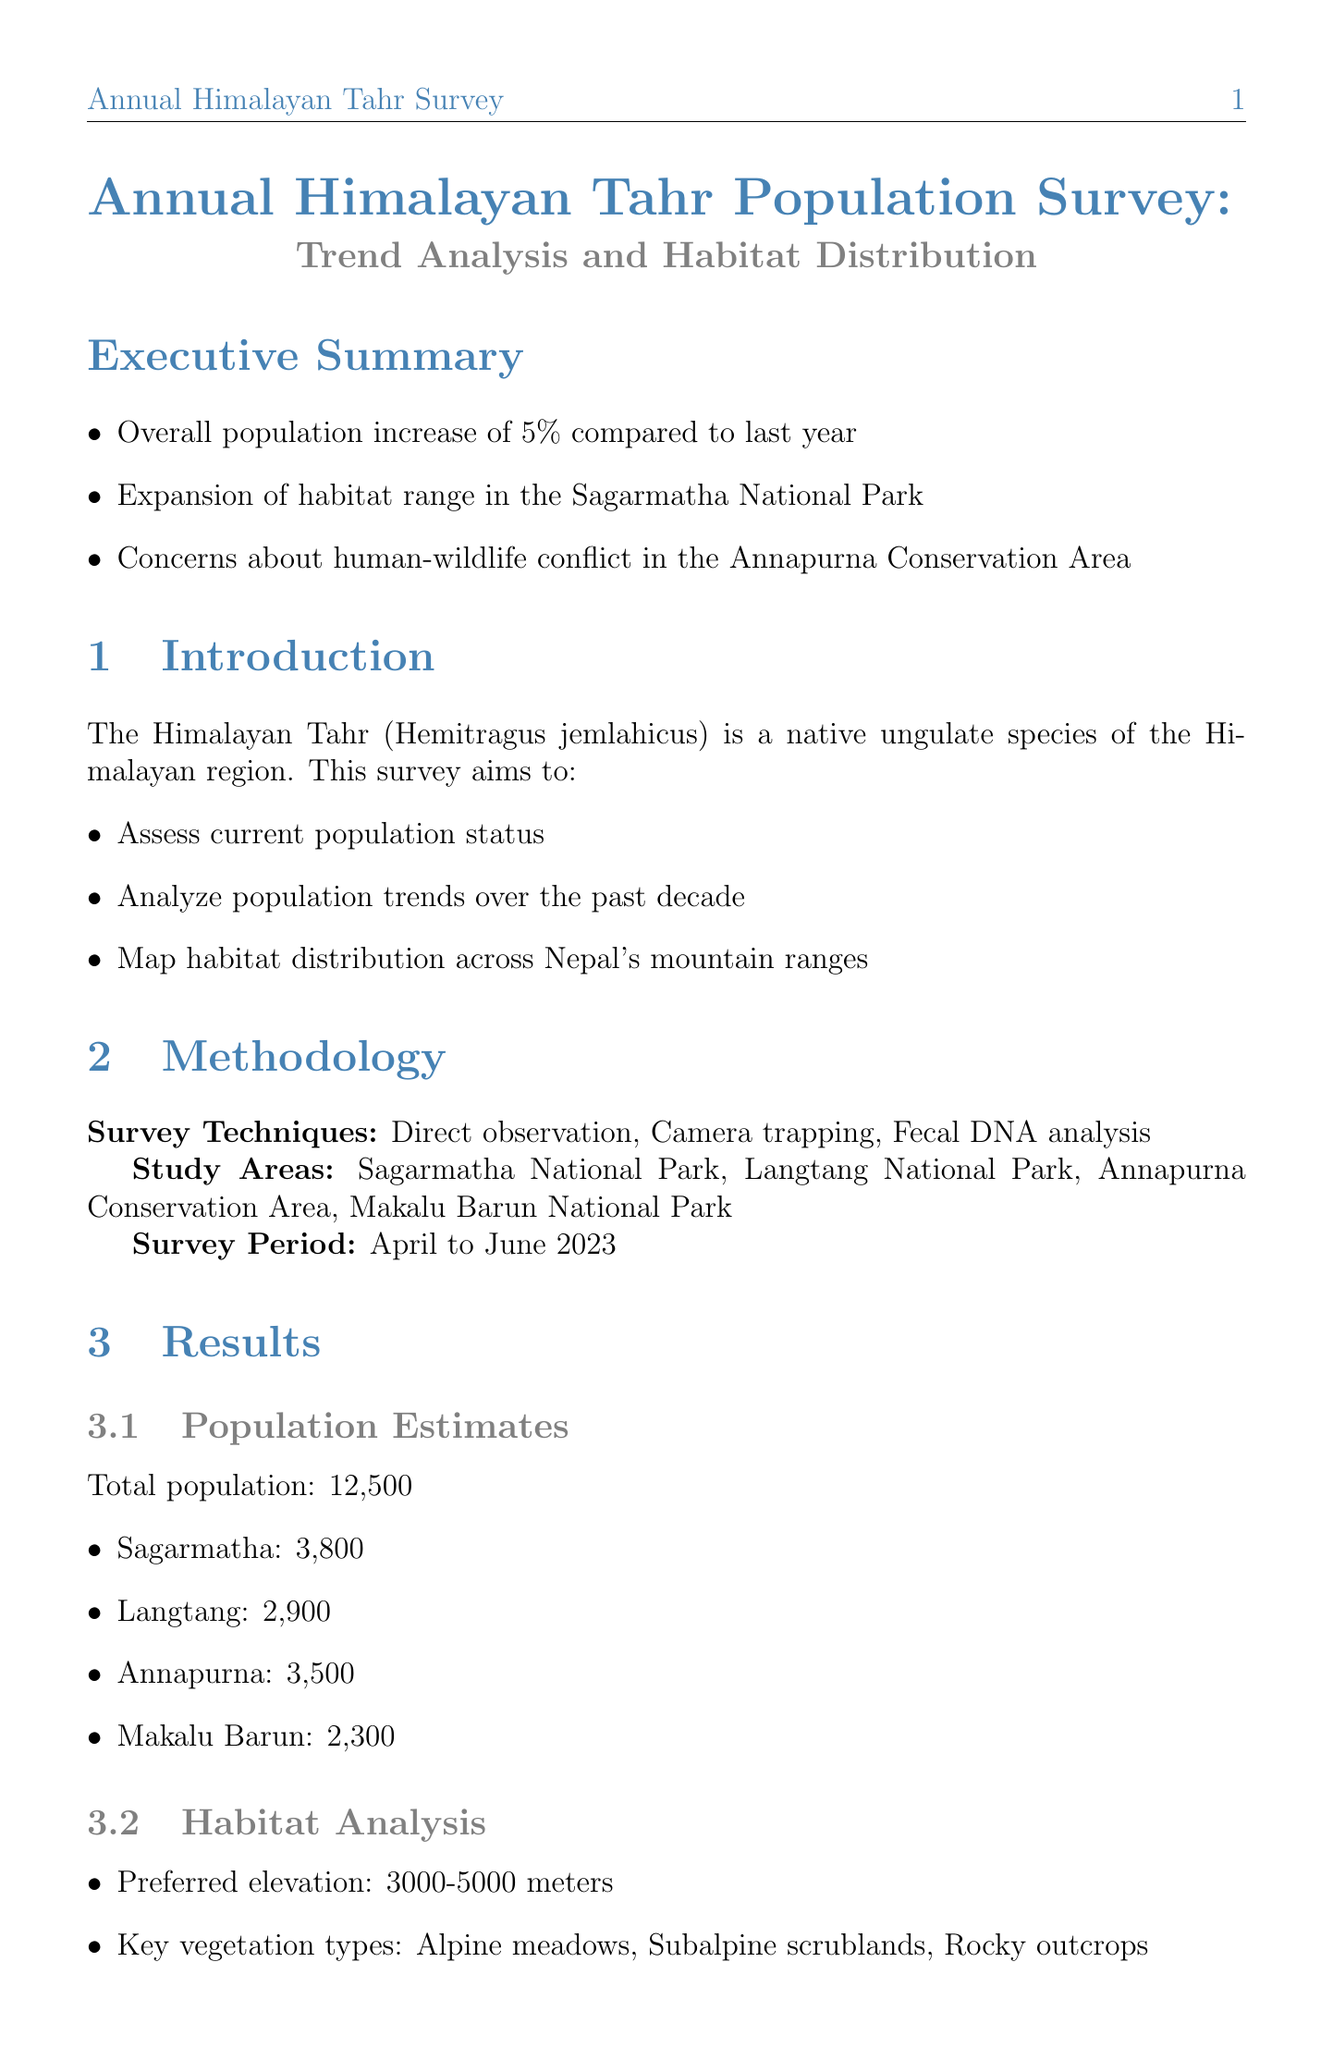What is the total population of Himalayan Tahr? The document states that the total population of Himalayan Tahr is 12,500.
Answer: 12,500 What is the survey period for the population survey? The survey period conducted was from April to June 2023.
Answer: April to June 2023 What percentage increase in population was observed compared to last year? The report indicates an overall population increase of 5% compared to last year.
Answer: 5% Which national park showed a habitat expansion? The document notes an expansion of habitat range in Sagarmatha National Park.
Answer: Sagarmatha National Park What are the key vegetation types preferred by Himalayan Tahr? The report lists key vegetation types as Alpine meadows, Subalpine scrublands, and Rocky outcrops.
Answer: Alpine meadows, Subalpine scrublands, Rocky outcrops What is the annual population growth rate over the past five years? The revelation of a 2.5% annual increase over the past five years is provided in the document.
Answer: 2.5% Which region has the highest population of Himalayan Tahr according to the distribution? The population distribution shows that the Annapurna region has the highest population at 3,500.
Answer: Annapurna What management implication is suggested for Langtang National Park? The document suggests a need for increased anti-poaching efforts in Langtang National Park.
Answer: Increased anti-poaching efforts What is one of the conservation challenges mentioned in the report? Climate change impacts on high-altitude habitats is described as one of the conservation challenges.
Answer: Climate change impacts 